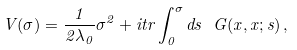Convert formula to latex. <formula><loc_0><loc_0><loc_500><loc_500>V ( \sigma ) = \frac { 1 } { 2 \lambda _ { 0 } } \sigma ^ { 2 } + i t r \int ^ { \sigma } _ { 0 } d s \ G ( x , x ; s ) \, ,</formula> 